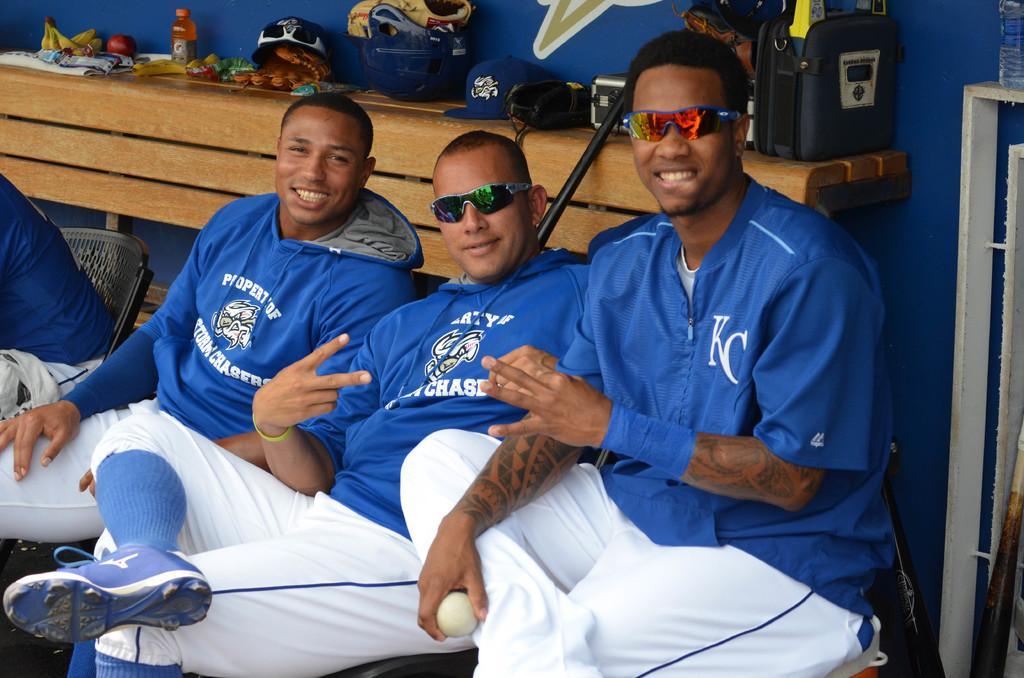Describe this image in one or two sentences. Here we can see three men sitting on the chair and among them a person on the right is holding a ball in his hand. In the background there is a person sitting on the chair,on the table we can see bananas,fruits,bottles,helmet,cap,glove and some other items and on the right there is a water bottle on a stand and we can also see bats hear. 